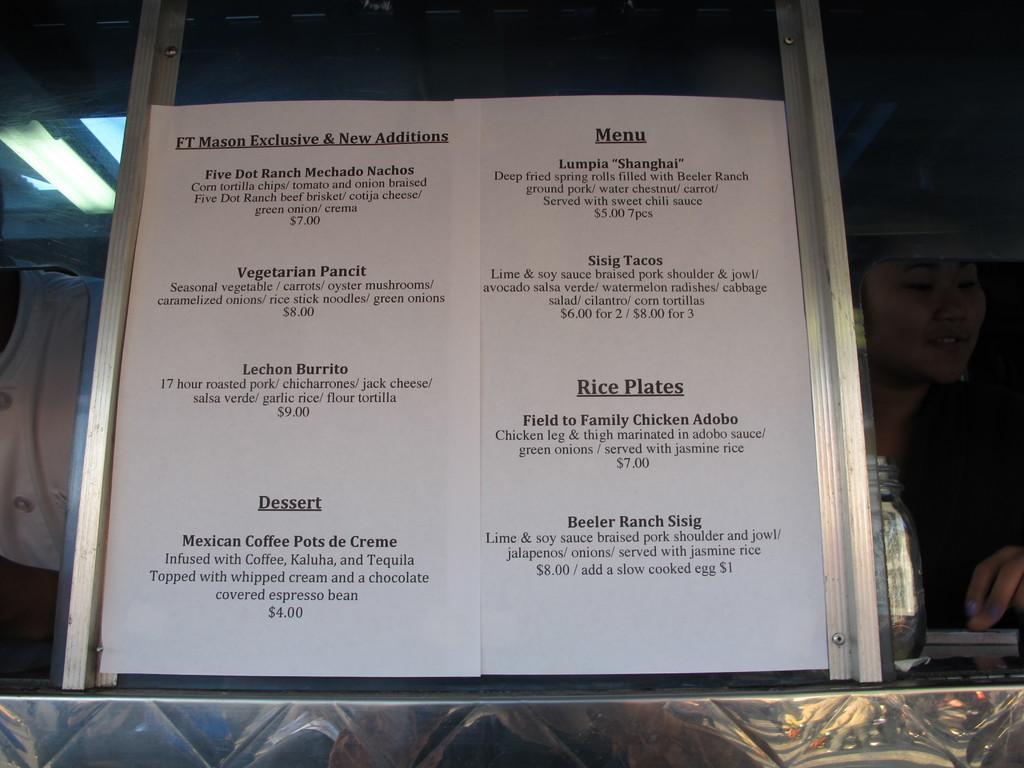Please provide a concise description of this image. In the center of the image we can see the pages with the text. On the left we can see a person and on the right there is a woman and also a bottle on the counter. We can also see the lights attached to the ceiling. 